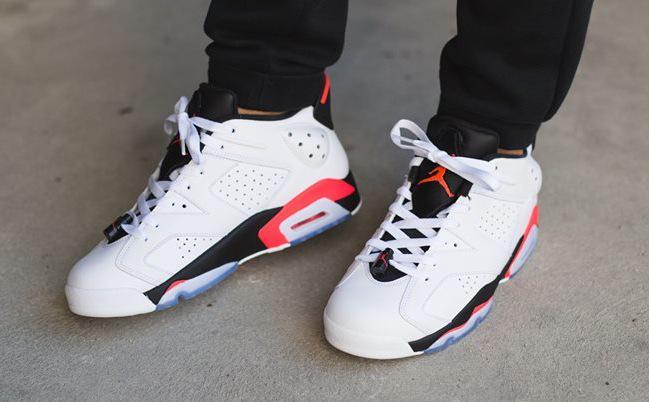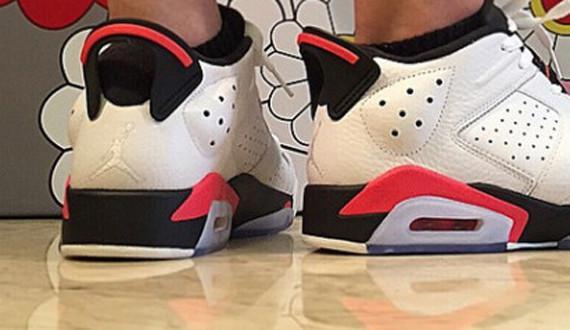The first image is the image on the left, the second image is the image on the right. Assess this claim about the two images: "At least one pair of sneakers is not shown worn by a person, and at least one pair of sneakers has red-and-white coloring.". Correct or not? Answer yes or no. No. The first image is the image on the left, the second image is the image on the right. Considering the images on both sides, is "At least one pair of shoes does not have any red color in it." valid? Answer yes or no. No. 